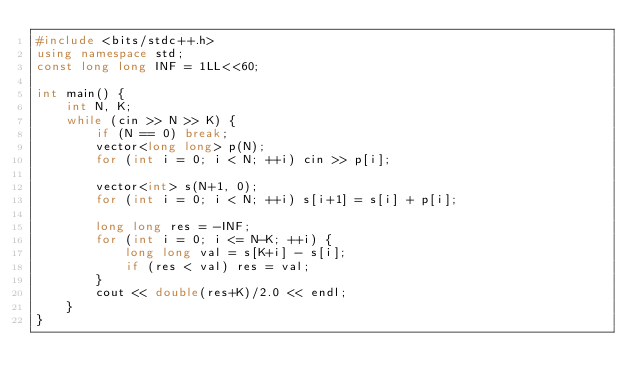<code> <loc_0><loc_0><loc_500><loc_500><_C++_>#include <bits/stdc++.h>
using namespace std;
const long long INF = 1LL<<60;

int main() {
    int N, K;
    while (cin >> N >> K) {
        if (N == 0) break;
        vector<long long> p(N);
        for (int i = 0; i < N; ++i) cin >> p[i];

        vector<int> s(N+1, 0);
        for (int i = 0; i < N; ++i) s[i+1] = s[i] + p[i];

        long long res = -INF;
        for (int i = 0; i <= N-K; ++i) {
            long long val = s[K+i] - s[i];
            if (res < val) res = val;
        }
        cout << double(res+K)/2.0 << endl;
    }
}</code> 